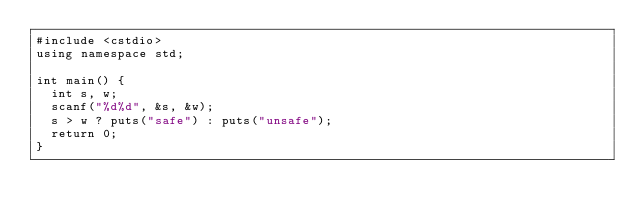Convert code to text. <code><loc_0><loc_0><loc_500><loc_500><_C++_>#include <cstdio>
using namespace std;

int main() {
  int s, w;
  scanf("%d%d", &s, &w);
  s > w ? puts("safe") : puts("unsafe");
  return 0;
}</code> 